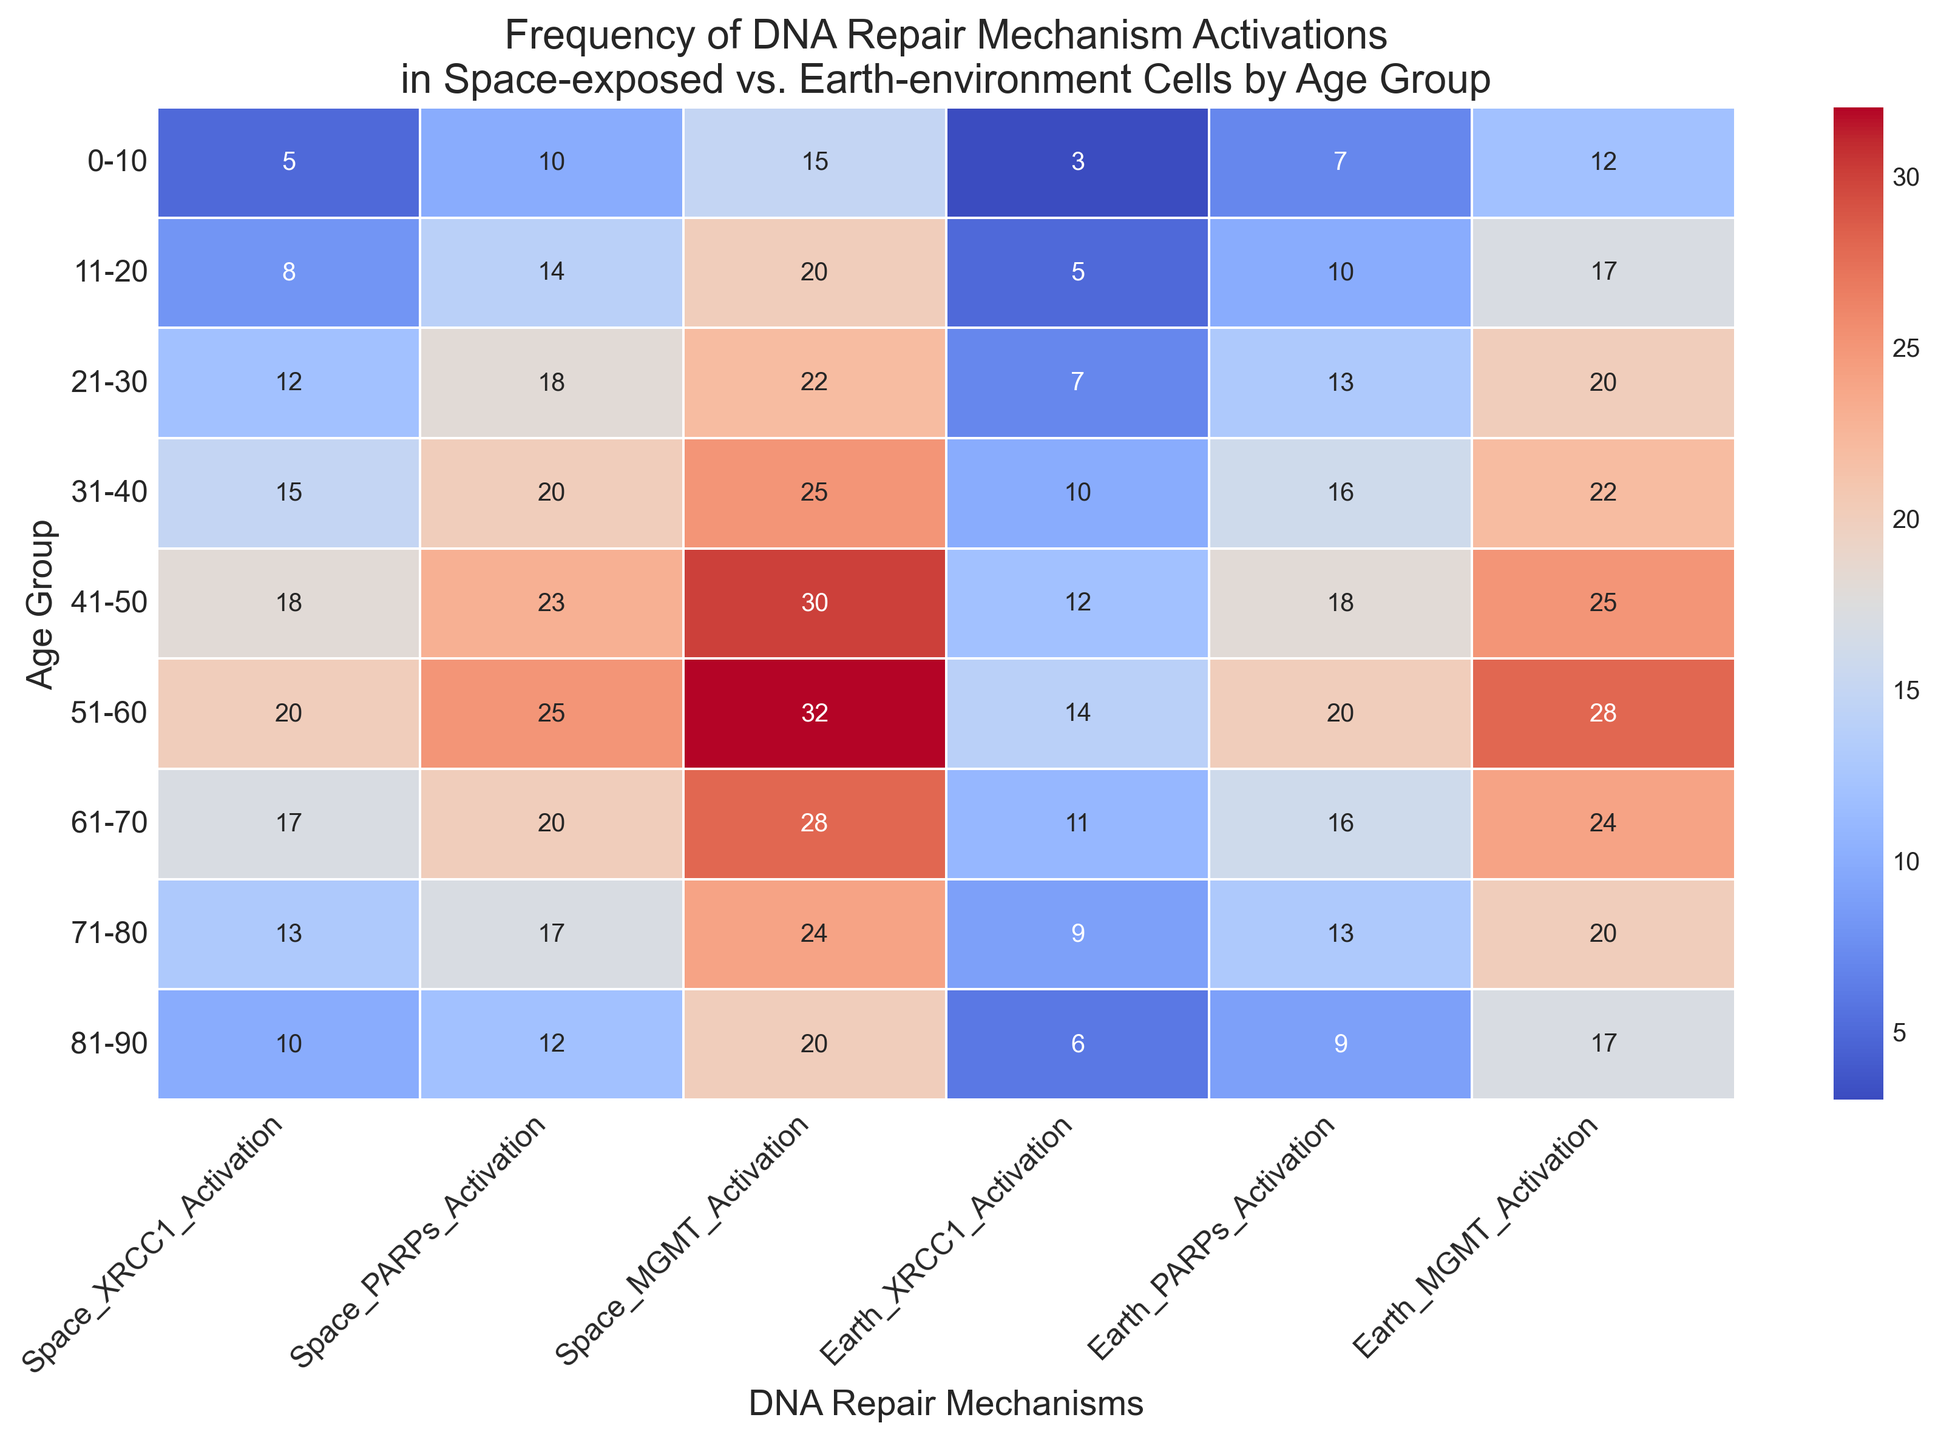What age group shows the highest activation of XRCC1 in space-exposed cells? Look at the row with the highest visual mark for 'Space_XRCC1_Activation' and identify the corresponding age group. The '31-40' age group has the highest value of 20.
Answer: 31-40 Compare the activation of PARPs between space-exposed and earth-environment cells for the 51-60 age group. Compare the values under 'Space_PARPs_Activation' and 'Earth_PARPs_Activation' for the '51-60' age group. Space activation is 25 and earth activation is 20, thus space activation is higher.
Answer: Space: 25, Earth: 20 Which DNA repair mechanism shows the least activation in earth-environment cells for the 0-10 age group? Examine the visual marks for 'Earth_XRCC1_Activation', 'Earth_PARPs_Activation', and 'Earth_MGMT_Activation' for the '0-10' age group. The smallest value is for 'Earth_XRCC1_Activation' which is 3.
Answer: XRCC1 Calculate the difference in XRCC1 activation between space-exposed and earth-environment cells for the 21-30 age group. Subtract the value of 'Earth_XRCC1_Activation' from 'Space_XRCC1_Activation' for the '21-30' age group: 12 - 7 = 5.
Answer: 5 How does MGMT activation in space-exposed cells change from the 31-40 to 41-50 age group? Identify the values under 'Space_MGMT_Activation' for '31-40' (25) and '41-50' (30). The difference is 30 - 25 = 5, indicating an increase.
Answer: Increases by 5 Which age group shows the smallest gap in activation of PARPs between space-exposed and earth-environment cells? Calculate the differences between 'Space_PARPs_Activation' and 'Earth_PARPs_Activation' for each age group. The smallest difference is in the '41-50' age group with a difference of 23 - 18 = 5.
Answer: 41-50 What is the sum of MGMT activation in space-exposed cells across all age groups? Add all the values in the 'Space_MGMT_Activation' column: 15 + 20 + 22 + 25 + 30 + 32 + 28 + 24 + 20 = 216.
Answer: 216 Which age group has the most significant increase in activation of XRCC1 when comparing space-exposed to earth-environment cells? Calculate the differences between 'Space_XRCC1_Activation' and 'Earth_XRCC1_Activation' for each age group and identify the largest one. The biggest increase is in the '51-60' age group (20 - 14 = 6).
Answer: 51-60 Is there an age group where the activation of any repair mechanism is the same for both space-exposed and earth-environment cells? Compare corresponding values for space and earth for all DNA repair mechanisms for all age groups. No values are equal in all the provided data columns.
Answer: No 